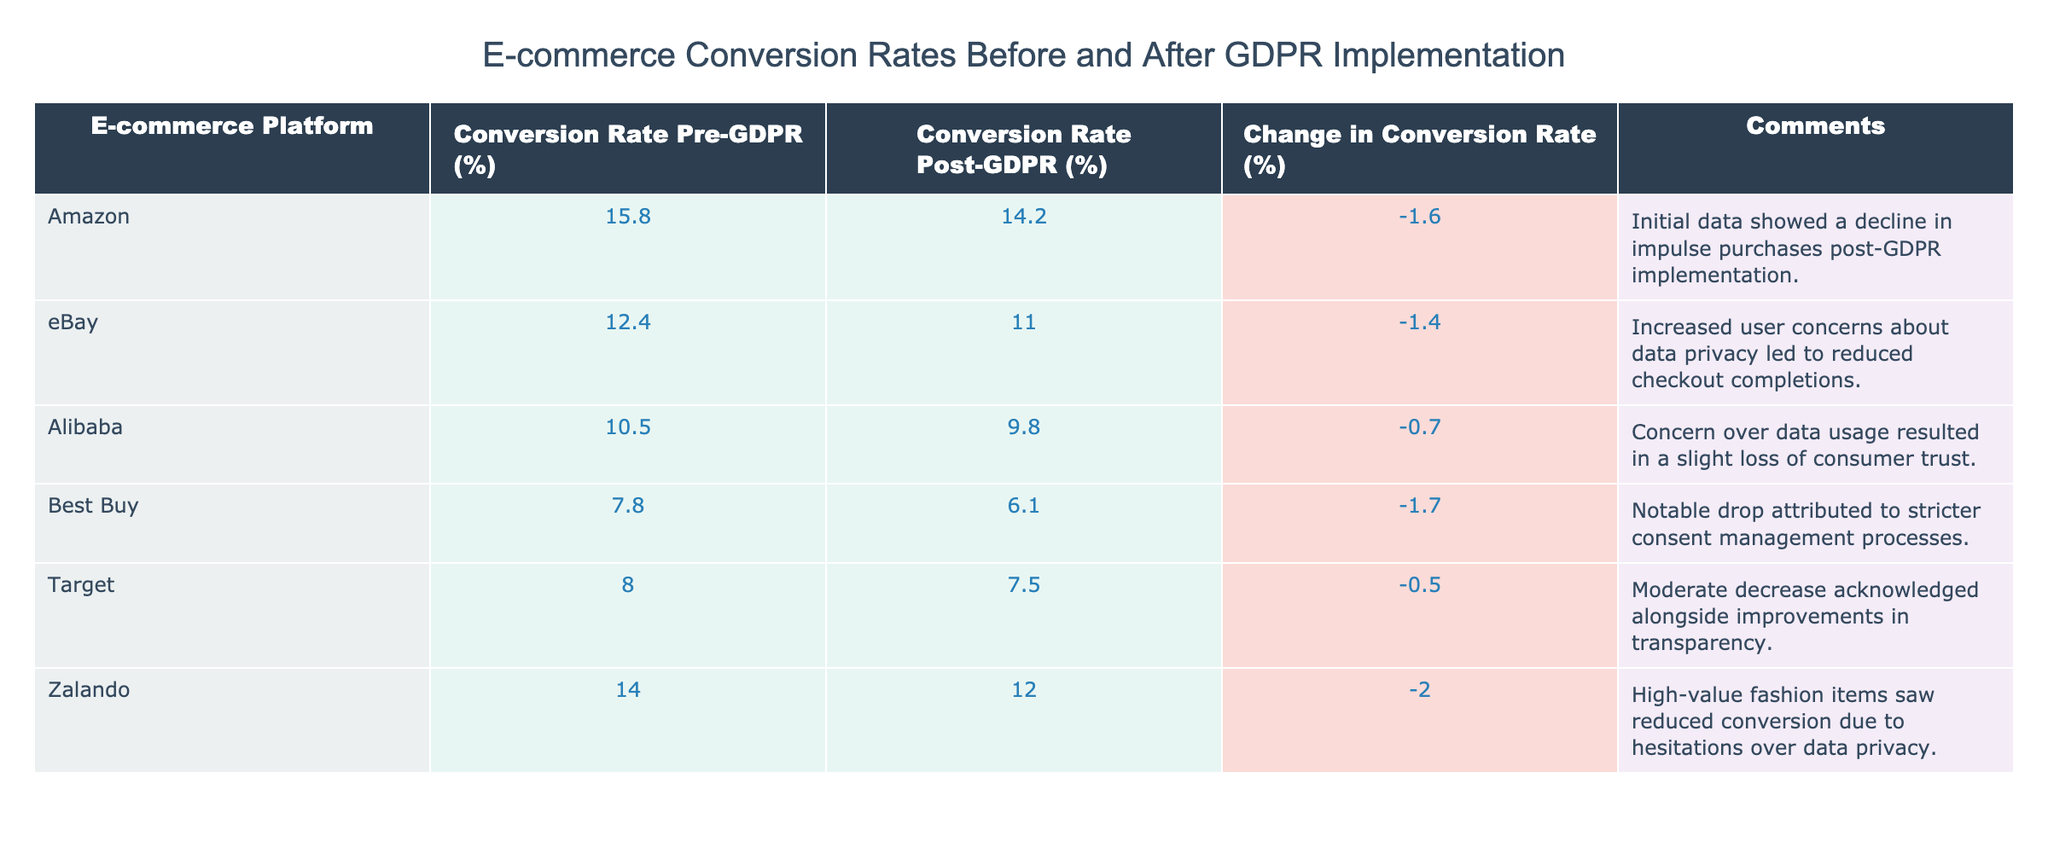What was the conversion rate for Amazon before GDPR implementation? The table indicates that the conversion rate for Amazon before GDPR was 15.8%. This value can be found in the row corresponding to Amazon under the "Conversion Rate Pre-GDPR (%)" column.
Answer: 15.8% What was the largest decrease in conversion rate recorded among the platforms? By examining the "Change in Conversion Rate (%)" column, the largest decrease is -2.0%, which corresponds to Zalando. This value is the lowest among all listed platforms.
Answer: -2.0% Did eBay experience an increase in its conversion rate post-GDPR? Looking at the "Conversion Rate Post-GDPR (%)" for eBay, it shows 11.0%, which is lower than the pre-GDPR rate of 12.4%. Therefore, eBay did not experience an increase.
Answer: No What is the average conversion rate for all platforms post-GDPR? The post-GDPR rates are: 14.2, 11.0, 9.8, 6.1, 7.5, and 12.0. Adding them up gives 60.6; there are 6 platforms, so the average is 60.6 / 6 = 10.1.
Answer: 10.1 Which platform had a change in conversion rate closest to zero? To find this, we review the "Change in Conversion Rate (%)" column and see that Target has a change of -0.5%, which is the closest to zero compared to others.
Answer: Target 